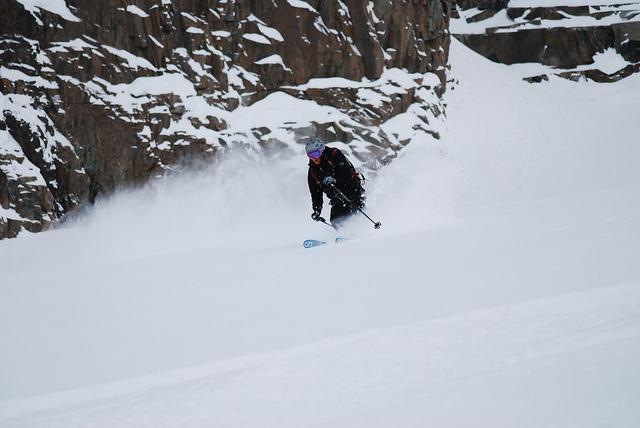How many giraffes have visible legs?
Give a very brief answer. 0. 